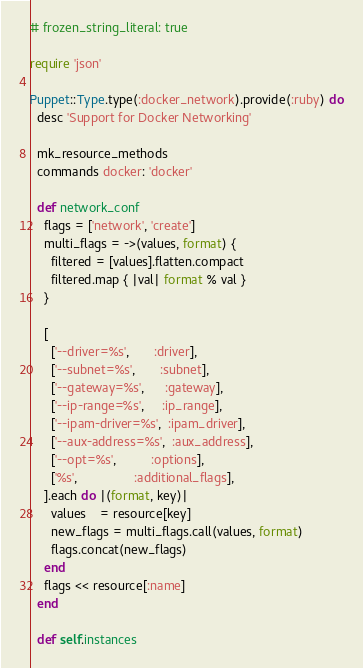<code> <loc_0><loc_0><loc_500><loc_500><_Ruby_># frozen_string_literal: true

require 'json'

Puppet::Type.type(:docker_network).provide(:ruby) do
  desc 'Support for Docker Networking'

  mk_resource_methods
  commands docker: 'docker'

  def network_conf
    flags = ['network', 'create']
    multi_flags = ->(values, format) {
      filtered = [values].flatten.compact
      filtered.map { |val| format % val }
    }

    [
      ['--driver=%s',       :driver],
      ['--subnet=%s',       :subnet],
      ['--gateway=%s',      :gateway],
      ['--ip-range=%s',     :ip_range],
      ['--ipam-driver=%s',  :ipam_driver],
      ['--aux-address=%s',  :aux_address],
      ['--opt=%s',          :options],
      ['%s',                :additional_flags],
    ].each do |(format, key)|
      values    = resource[key]
      new_flags = multi_flags.call(values, format)
      flags.concat(new_flags)
    end
    flags << resource[:name]
  end

  def self.instances</code> 